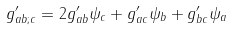<formula> <loc_0><loc_0><loc_500><loc_500>g ^ { \prime } _ { a b ; c } = 2 g ^ { \prime } _ { a b } \psi _ { c } + g ^ { \prime } _ { a c } \psi _ { b } + g ^ { \prime } _ { b c } \psi _ { a }</formula> 